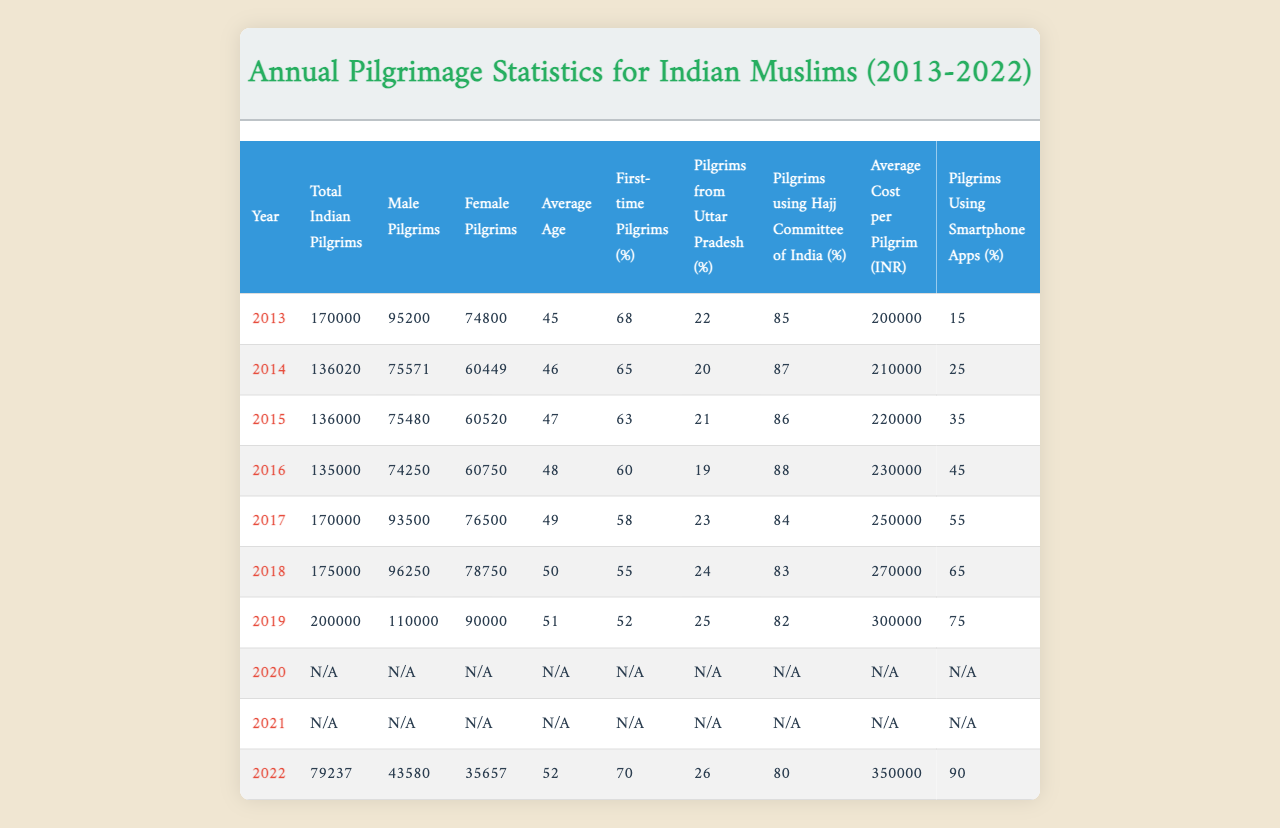What was the total number of Indian pilgrims in 2013? The total number of Indian pilgrims for the year 2013 is listed directly in the table under "Total Indian Pilgrims", which shows 170,000.
Answer: 170000 What percentage of pilgrims were first-time pilgrims in 2018? The table indicates that 55% of the pilgrims in 2018 were first-time pilgrims, as specified under "First-time Pilgrims (%)".
Answer: 55% How many male pilgrims visited Mecca in 2022? In 2022, the table shows that the number of male pilgrims was recorded as 43,580, under the column "Male Pilgrims".
Answer: 43580 What was the average cost per pilgrim in 2015 and how does it compare to 2022? For the year 2015, the average cost per pilgrim was 220,000 INR. In 2022, it was 350,000 INR. The difference is 350,000 - 220,000 = 130,000 INR.
Answer: 130000 In which year did the percentage of pilgrims using smartphone apps reach 90%? According to the table, the percentage of pilgrims using smartphone apps reached 90% in the year 2022, as stated under "Pilgrims Using Smartphone Apps (%)".
Answer: 2022 What is the average age of pilgrims in 2016 and how does it compare to 2019? The average age of pilgrims in 2016 was 48, while in 2019 it was 51. The difference is 51 - 48 = 3 years, indicating an increase in average age over these years.
Answer: 3 Was there a decline in the number of total Indian pilgrims from 2014 to 2015? Yes, the total number of Indian pilgrims in 2014 was 136,020 and in 2015 it was 136,000, which indicates a decline of 20 pilgrims.
Answer: Yes Which year had the highest number of female pilgrims and what was that number? The highest number of female pilgrims was recorded in 2019 with 90,000, as noted under "Female Pilgrims".
Answer: 90000 What was the trend in the average age of pilgrims from 2013 to 2022? From the table, the average age in 2013 was 45 and increased to 52 in 2022, suggesting an upward trend in the average age over the years.
Answer: Upward trend Did the percentage of pilgrims using the Hajj Committee of India increase from 2016 to 2022? The percentage using the Hajj Committee of India decreased from 88% in 2016 to 80% in 2022, indicating a decline.
Answer: No How many total pilgrims visited Mecca over the entire period of 2013 to 2022 excluding 2020 and 2021? The total for 2013 to 2019 was 1,078,000. In 2022, there were 79,237. Thus, total = 1,078,000 + 79,237 = 1,157,237 pilgrims (excluding 2020 and 2021).
Answer: 1157237 